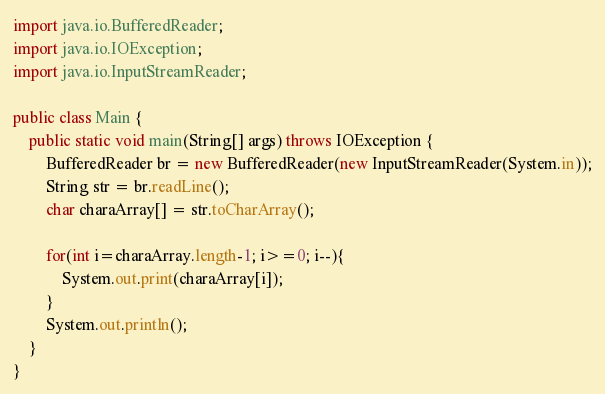Convert code to text. <code><loc_0><loc_0><loc_500><loc_500><_Java_>import java.io.BufferedReader;
import java.io.IOException;
import java.io.InputStreamReader;

public class Main {
	public static void main(String[] args) throws IOException {
		BufferedReader br = new BufferedReader(new InputStreamReader(System.in));
		String str = br.readLine();
		char charaArray[] = str.toCharArray();

		for(int i=charaArray.length-1; i>=0; i--){
			System.out.print(charaArray[i]);
		}
		System.out.println();
	}
}</code> 